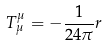<formula> <loc_0><loc_0><loc_500><loc_500>T _ { \mu } ^ { \mu } = - \frac { 1 } { 2 4 \pi } r</formula> 